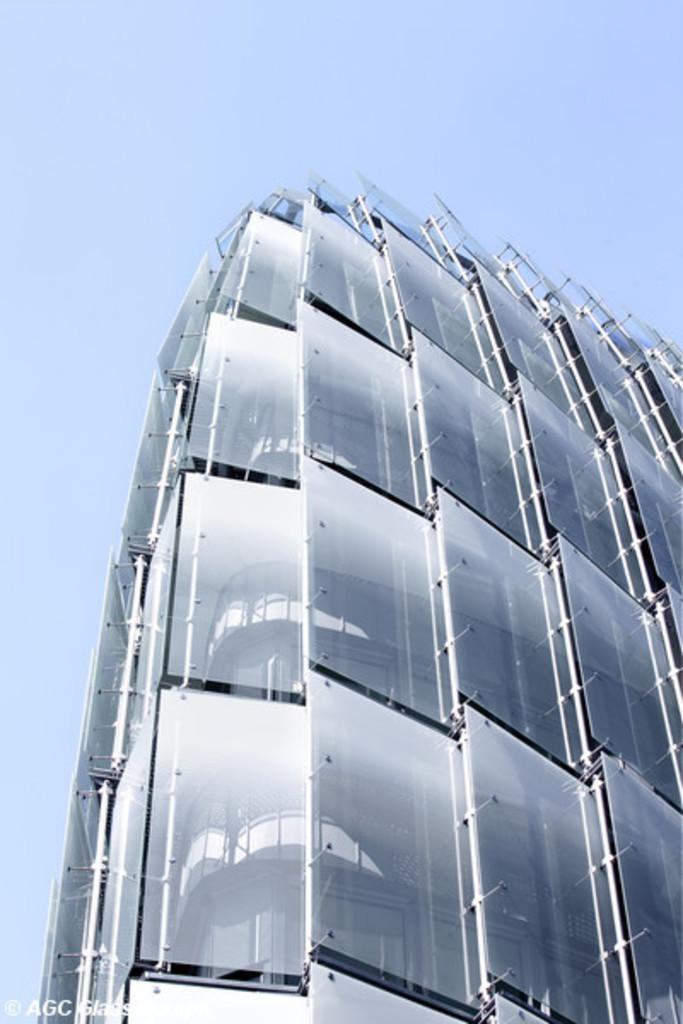What structure is the main subject of the image? There is a building in the image. What feature can be seen attached to the building? Glasses are attached to the building. What is the condition of the sky in the image? The sky is clear in the image. What is the weather like in the image? It is sunny in the image. What type of owl can be seen sitting on the glasses in the image? There is no owl present in the image; it only features a building with glasses attached to it. How much dirt is visible on the glasses in the image? There is no dirt visible on the glasses in the image; they appear clean. 